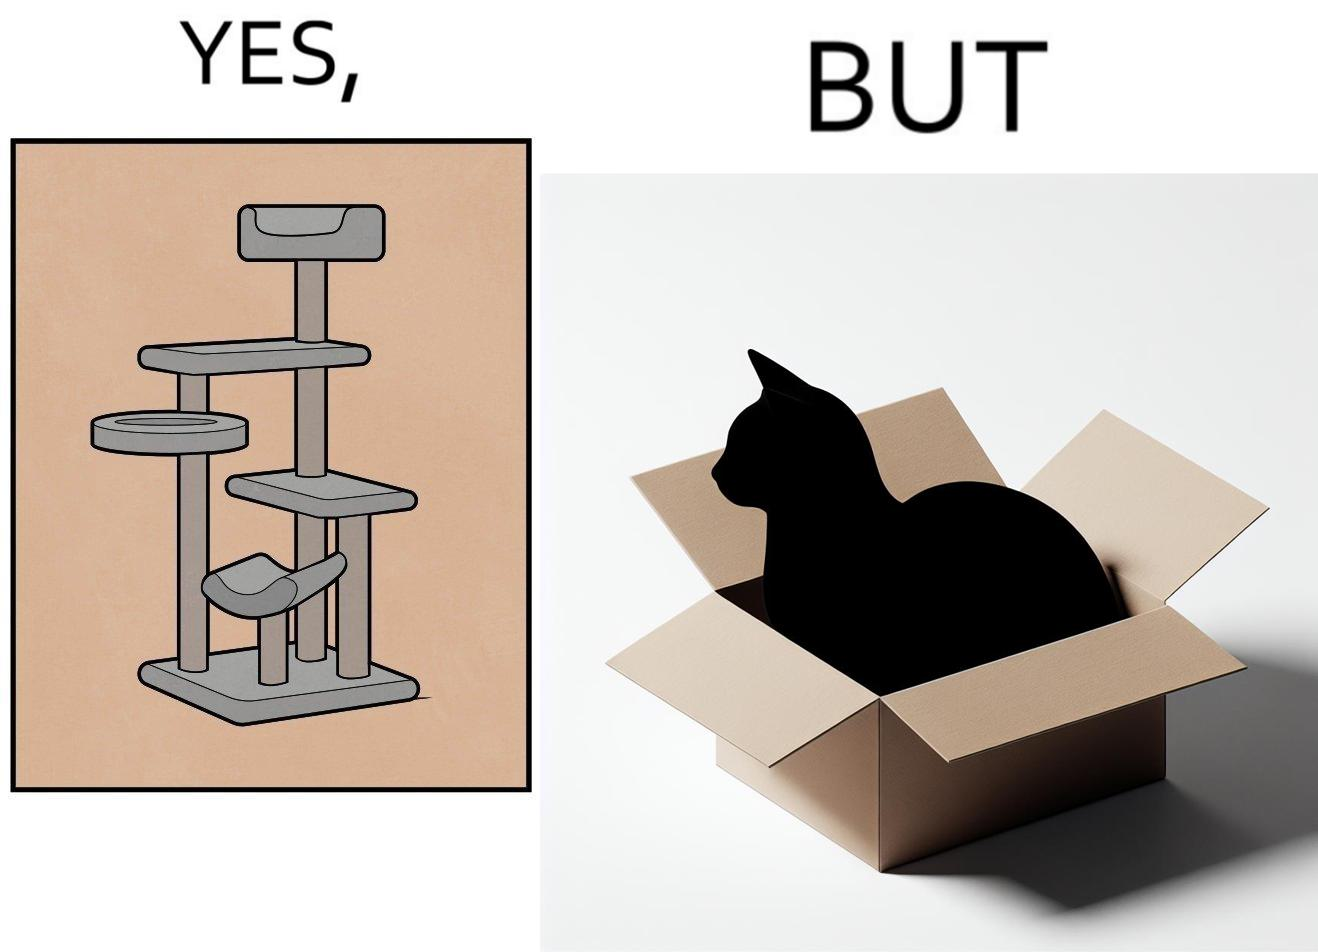Describe what you see in this image. The images are funny since even though a cat tree is bought for cats to play with, cats would usually rather play with inexpensive cardboard boxes because they enjoy it more 